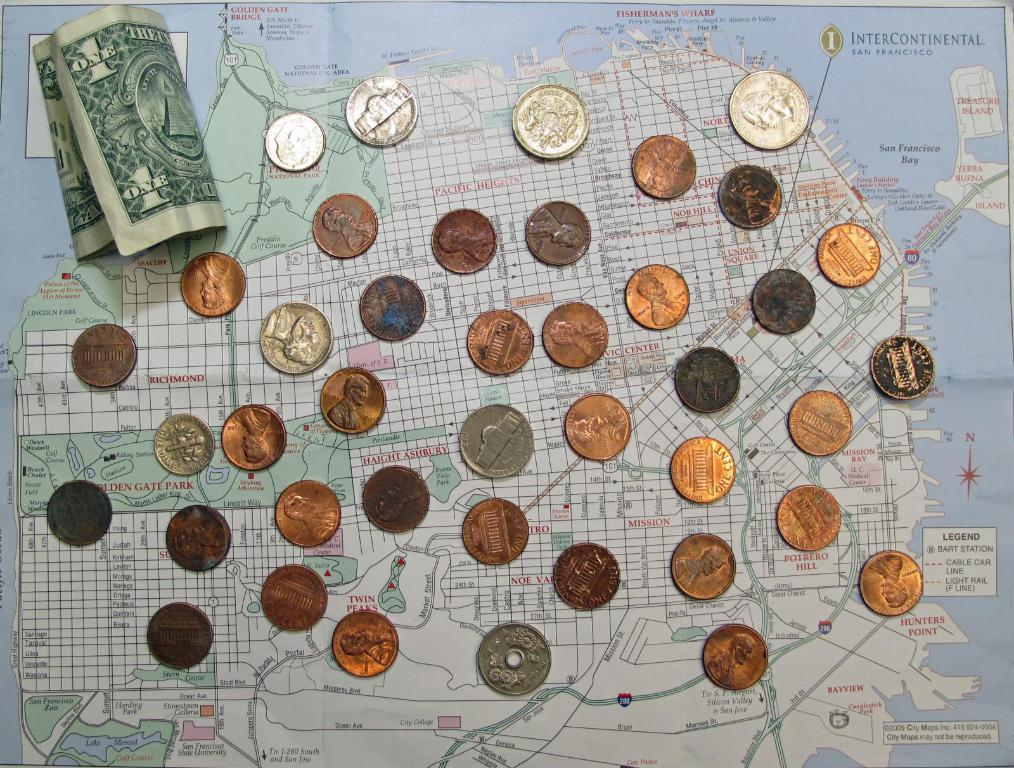<image>
Give a short and clear explanation of the subsequent image. several pennies and 1 dollar on map includes San Francisco Bay 